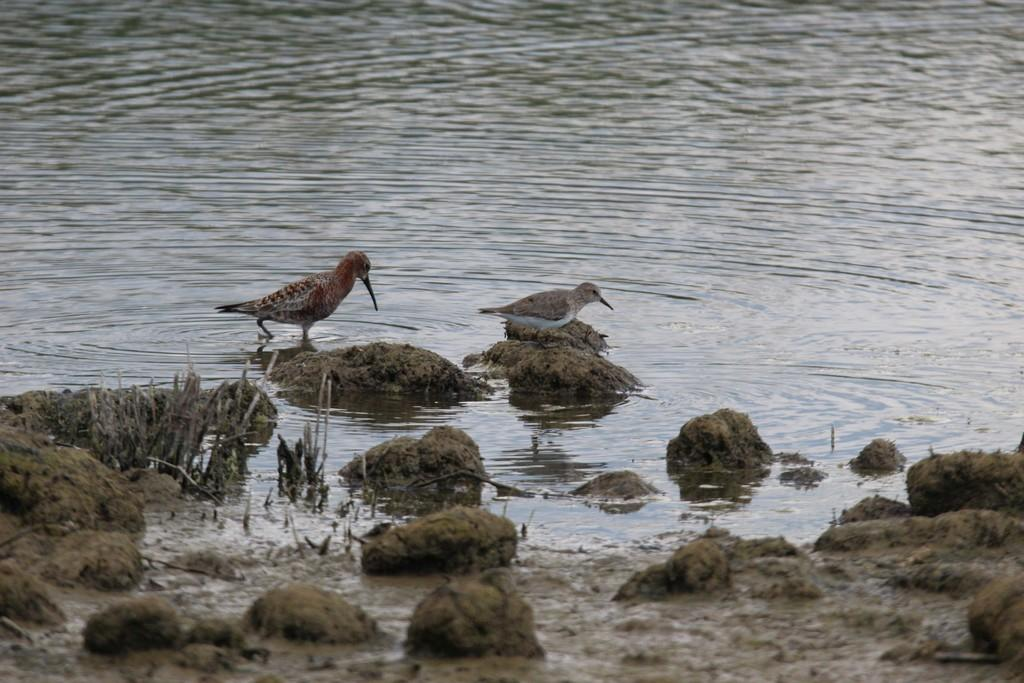How many birds are present in the image? There are two birds in the image. Where are the birds located? The birds are on the mud in the image. What is the mud situated in? The mud is in the water. What type of pear is being discussed in the language spoken by the birds in the image? There are no birds speaking any language in the image, and there is no mention of a pear. 